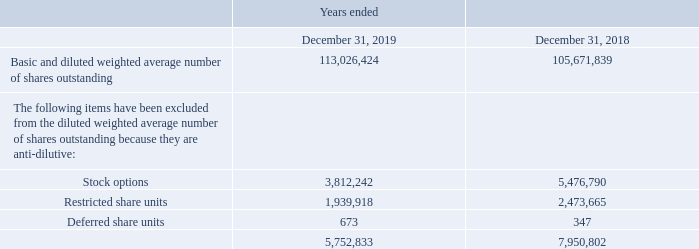Net Loss per Share
The Company applies the two-class method to calculate its basic and diluted net loss per share as both classes of its voting shares are participating securities with equal participation rights and are entitled to receive dividends on a share for share basis.
The following table summarizes the reconciliation of the basic weighted average number of shares outstanding and the diluted weighted average number of shares outstanding:
In the years ended December 31, 2019 and 2018, the Company was in a loss position and therefore diluted loss per share is equal to basic loss per share.
Which 3 financial items were excluded from the diluted weighted average number of outstanding shares? Stock options, restricted share units, deferred share units. What financial information does the table show? Reconciliation of the basic weighted average number of shares outstanding and the diluted weighted average number of shares outstanding. What is the number of deferred share units in 2019? 673. What is the average anti-dilutive stock options for 2018 and 2019? (3,812,242+5,476,790)/2
Answer: 4644516. What is the average anti-dilutive restricted share units for 2018 and 2019? (1,939,918+2,473,665)/2
Answer: 2206791.5. What is the average anti-dilutive deferred share units for 2018 and 2019? (673+347)/2
Answer: 510. 